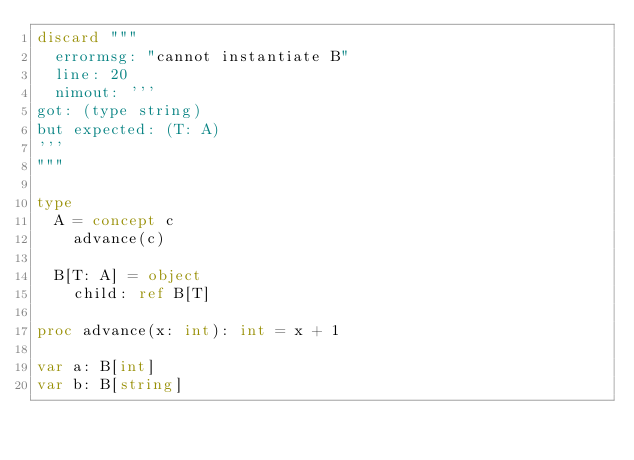Convert code to text. <code><loc_0><loc_0><loc_500><loc_500><_Nim_>discard """
  errormsg: "cannot instantiate B"
  line: 20
  nimout: '''
got: (type string)
but expected: (T: A)
'''
"""

type
  A = concept c
    advance(c)
  
  B[T: A] = object
    child: ref B[T]

proc advance(x: int): int = x + 1

var a: B[int]
var b: B[string]

</code> 